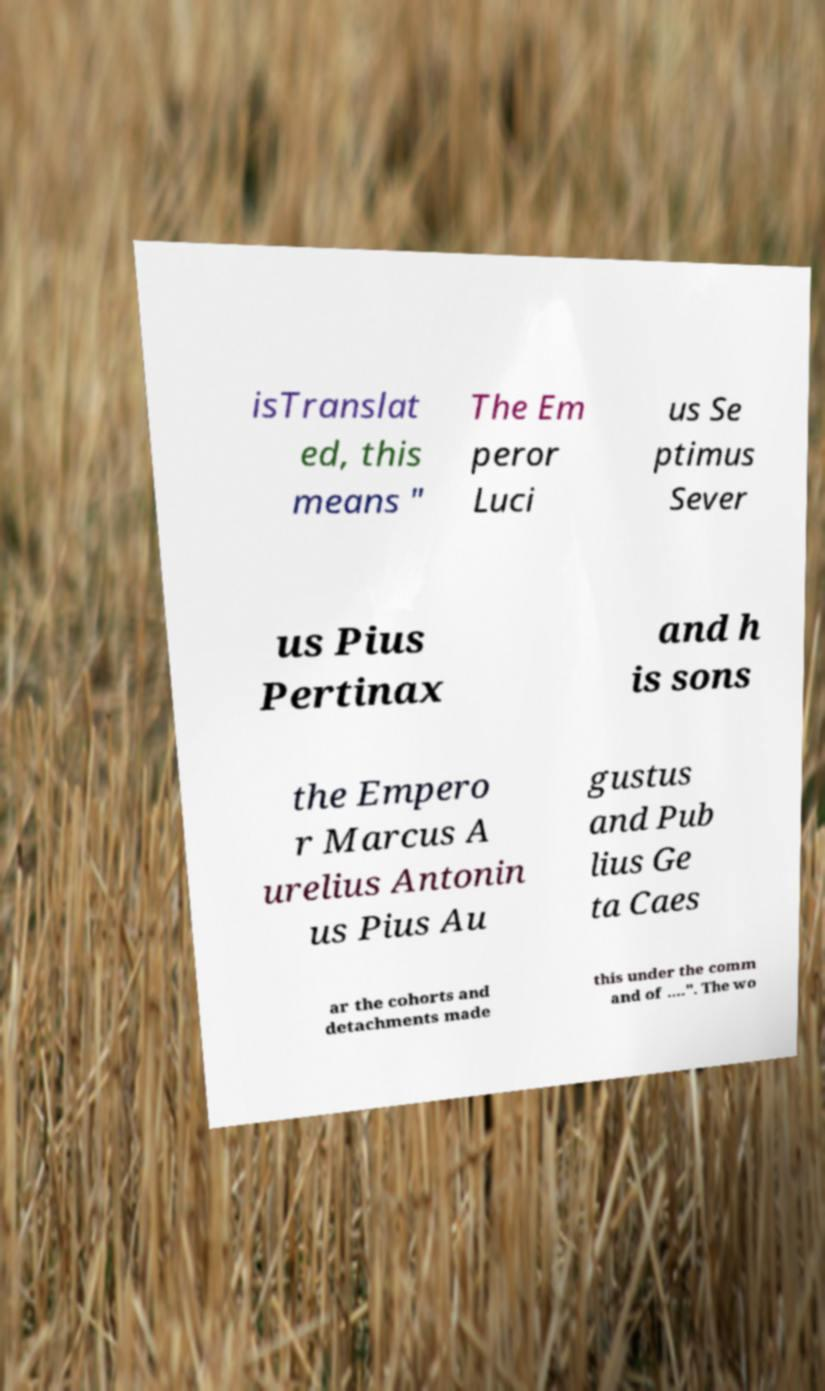For documentation purposes, I need the text within this image transcribed. Could you provide that? isTranslat ed, this means " The Em peror Luci us Se ptimus Sever us Pius Pertinax and h is sons the Empero r Marcus A urelius Antonin us Pius Au gustus and Pub lius Ge ta Caes ar the cohorts and detachments made this under the comm and of ….". The wo 